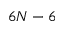Convert formula to latex. <formula><loc_0><loc_0><loc_500><loc_500>6 N - 6</formula> 